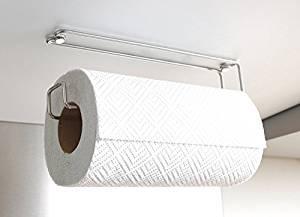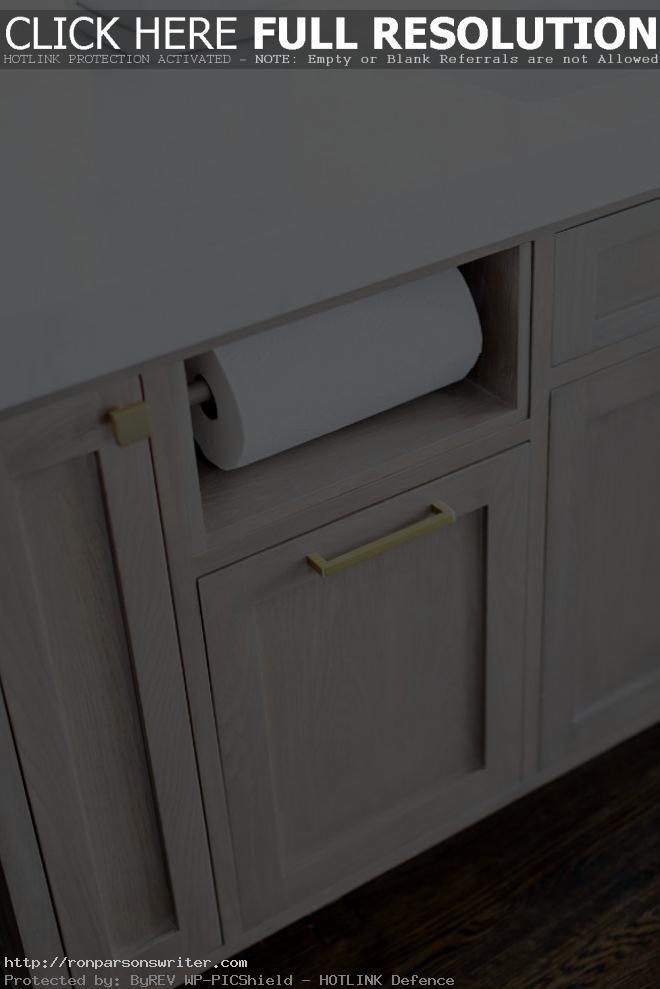The first image is the image on the left, the second image is the image on the right. Analyze the images presented: Is the assertion "The paper towels on the left are hanging under a cabinet." valid? Answer yes or no. Yes. The first image is the image on the left, the second image is the image on the right. Analyze the images presented: Is the assertion "An image shows a roll of towels suspended on a chrome wire bar mounted on the underside of a surface." valid? Answer yes or no. Yes. 